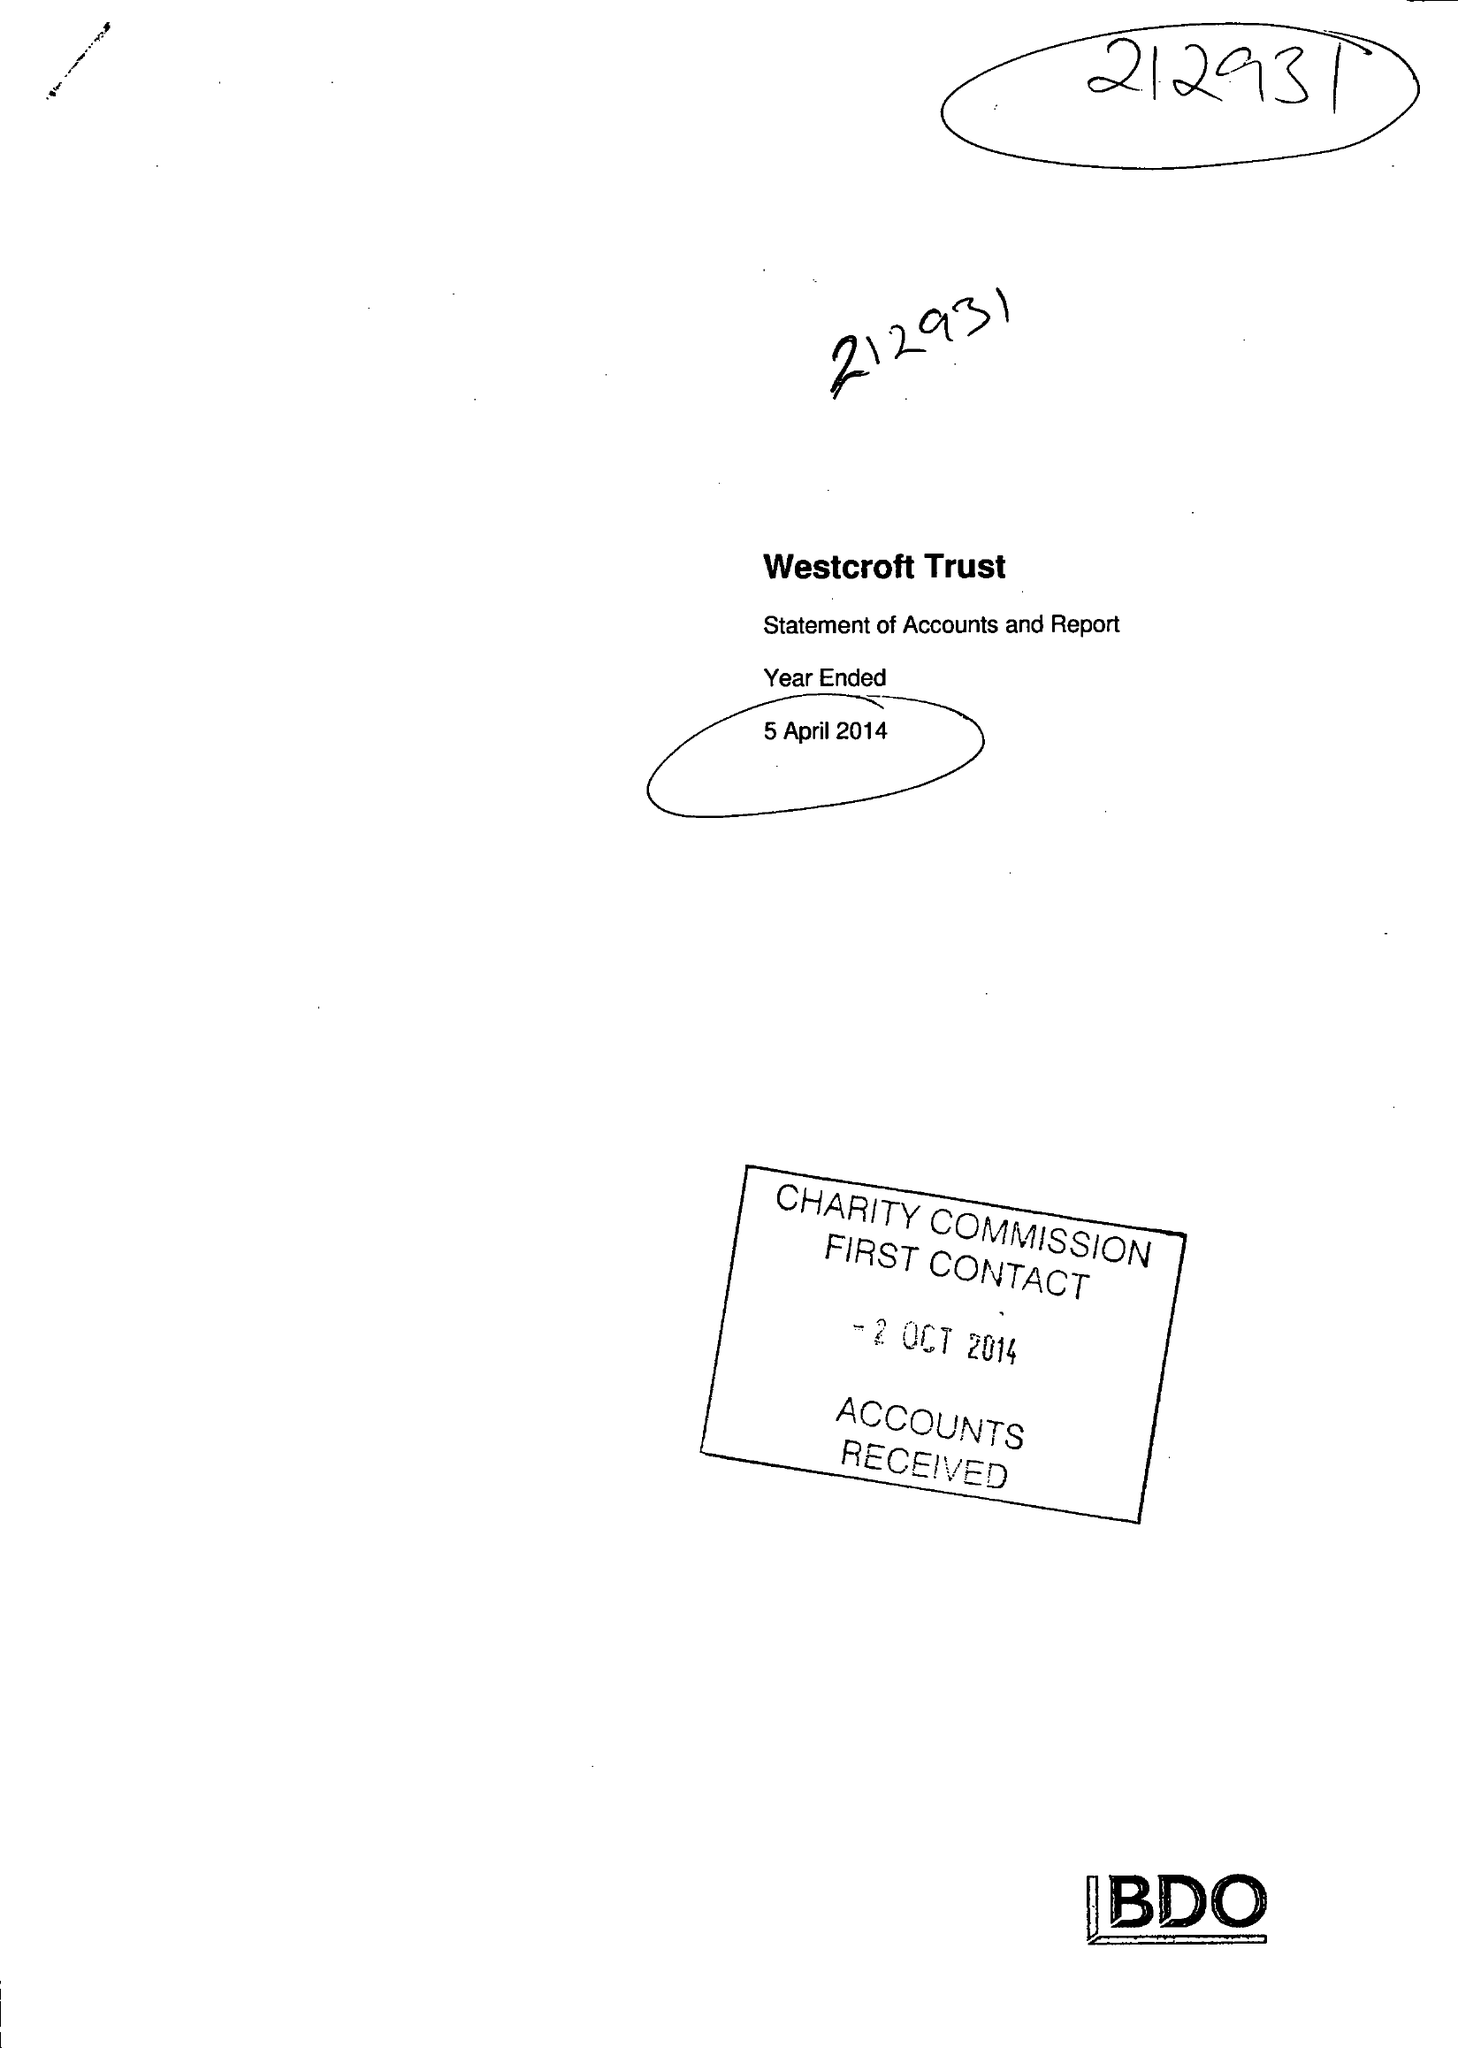What is the value for the income_annually_in_british_pounds?
Answer the question using a single word or phrase. 113325.00 